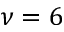<formula> <loc_0><loc_0><loc_500><loc_500>\nu = 6</formula> 